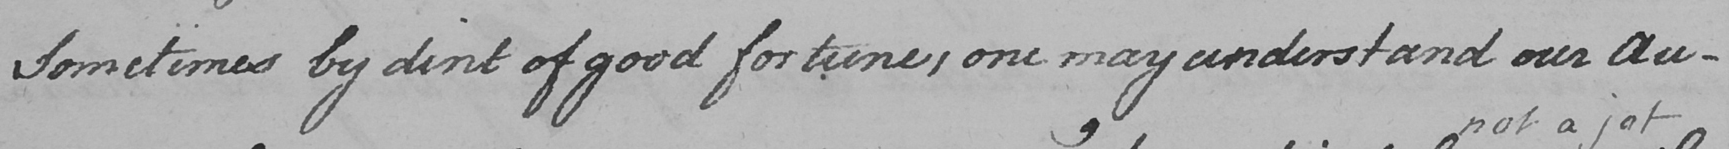Please transcribe the handwritten text in this image. Sometimes by dint of good fortune , one may understand our Au- 